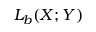<formula> <loc_0><loc_0><loc_500><loc_500>L _ { b } ( X ; Y )</formula> 